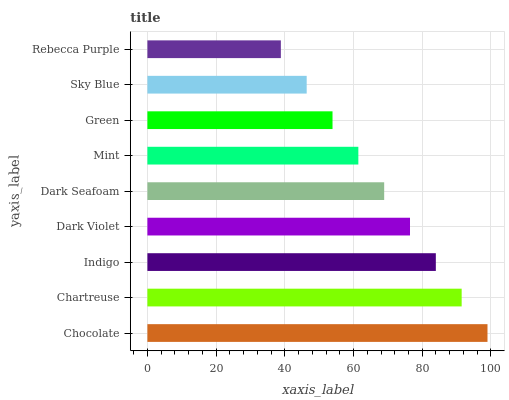Is Rebecca Purple the minimum?
Answer yes or no. Yes. Is Chocolate the maximum?
Answer yes or no. Yes. Is Chartreuse the minimum?
Answer yes or no. No. Is Chartreuse the maximum?
Answer yes or no. No. Is Chocolate greater than Chartreuse?
Answer yes or no. Yes. Is Chartreuse less than Chocolate?
Answer yes or no. Yes. Is Chartreuse greater than Chocolate?
Answer yes or no. No. Is Chocolate less than Chartreuse?
Answer yes or no. No. Is Dark Seafoam the high median?
Answer yes or no. Yes. Is Dark Seafoam the low median?
Answer yes or no. Yes. Is Rebecca Purple the high median?
Answer yes or no. No. Is Green the low median?
Answer yes or no. No. 